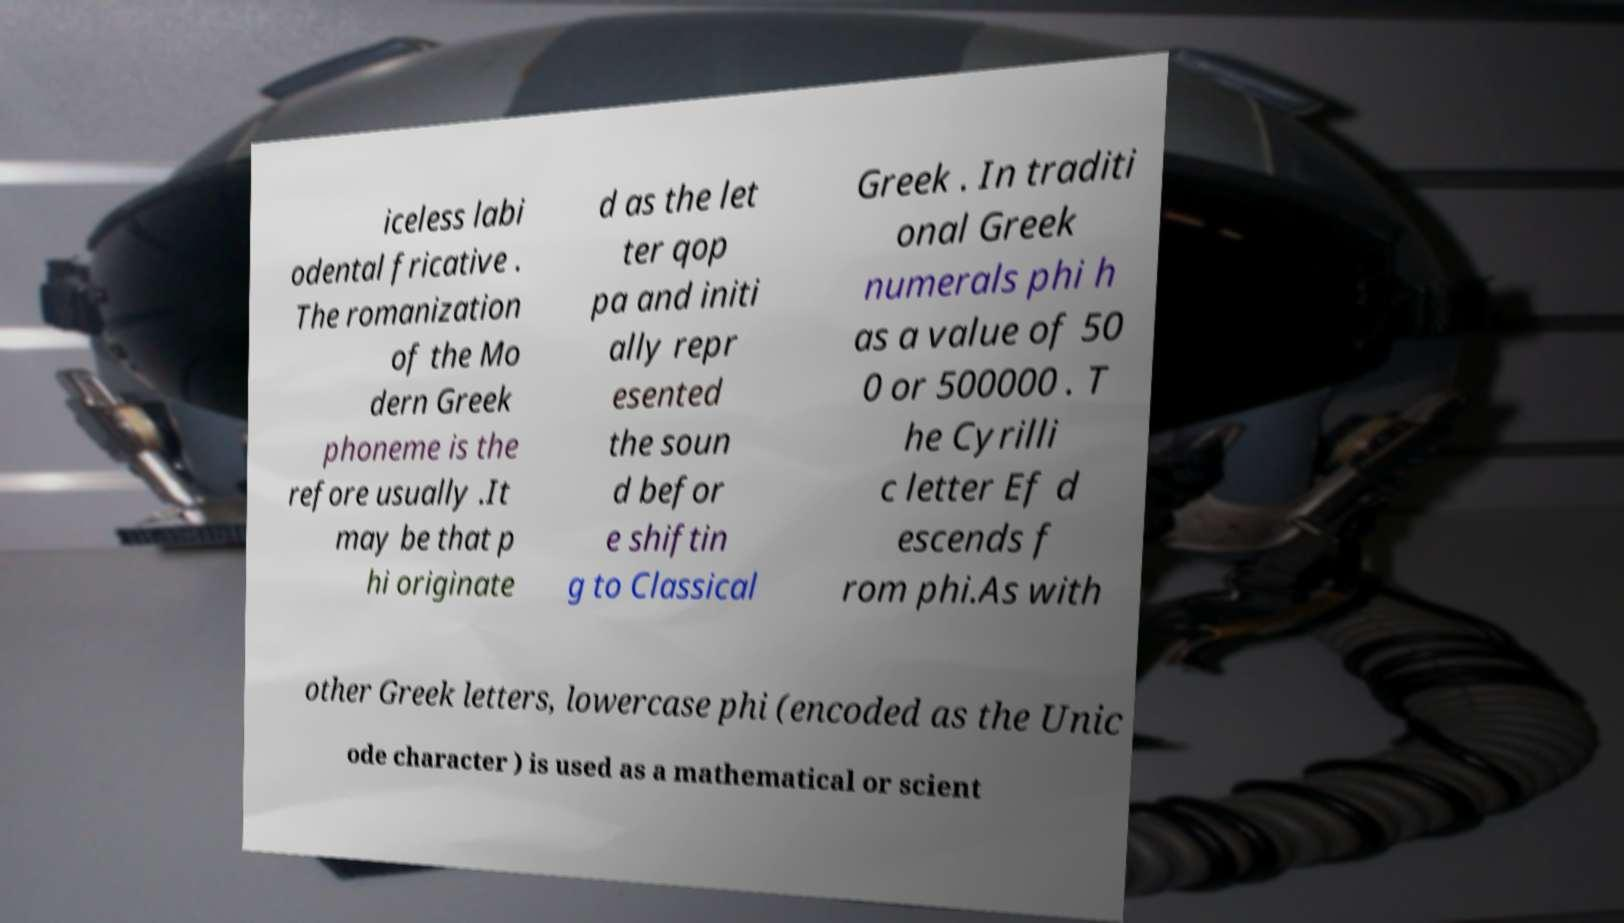Please read and relay the text visible in this image. What does it say? iceless labi odental fricative . The romanization of the Mo dern Greek phoneme is the refore usually .It may be that p hi originate d as the let ter qop pa and initi ally repr esented the soun d befor e shiftin g to Classical Greek . In traditi onal Greek numerals phi h as a value of 50 0 or 500000 . T he Cyrilli c letter Ef d escends f rom phi.As with other Greek letters, lowercase phi (encoded as the Unic ode character ) is used as a mathematical or scient 